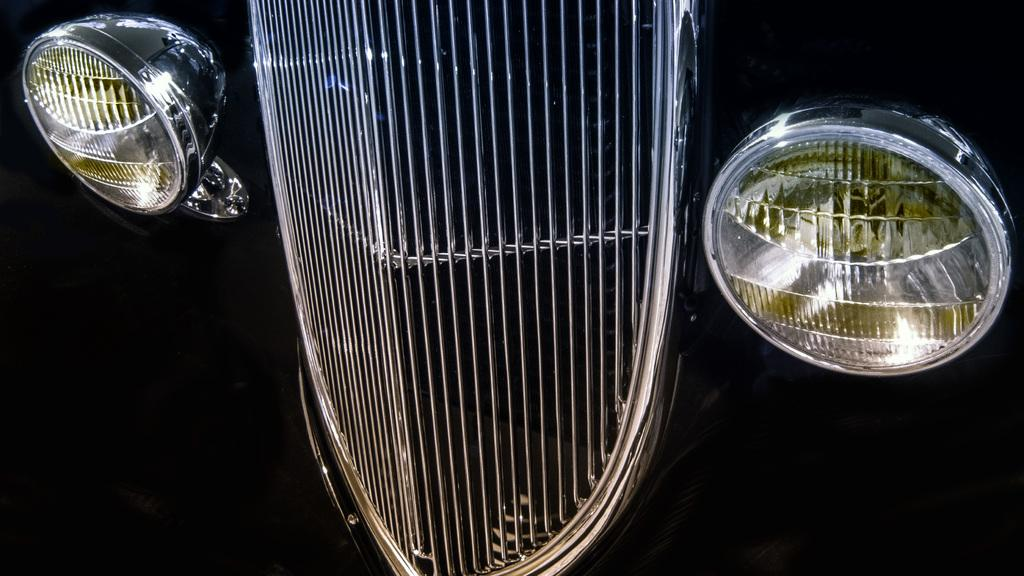What is the main subject of the image? The main subject of the image is a vehicle. Can you describe the lights on the vehicle? The vehicle has two lights, one on the left side and one on the right side. What is the color of the background in the image? The background of the image appears to be black. What type of nut is being tightened by the wrench in the image? There is no wrench or nut present in the image; it only features a vehicle with lights. Can you tell me how many cats are visible in the image? There are no cats present in the image. 